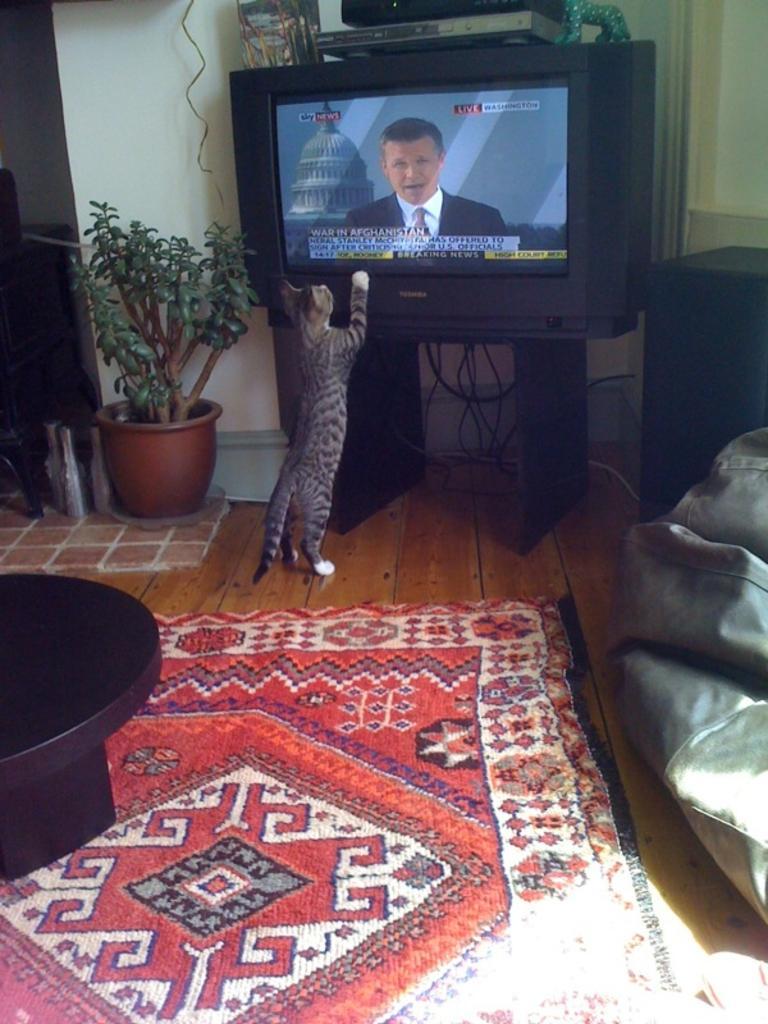Could you give a brief overview of what you see in this image? This picture is taken in a room. On the right side there is a couch on the center there is a t. v on. In front of the t. v there is a cat seeing a television on the left side there is a houseplant on the left side center table is black in colour and floor mat is on the floor In the background there is a wall and there is a D. V. D player which is kept on the t. v in the background there are wires. 